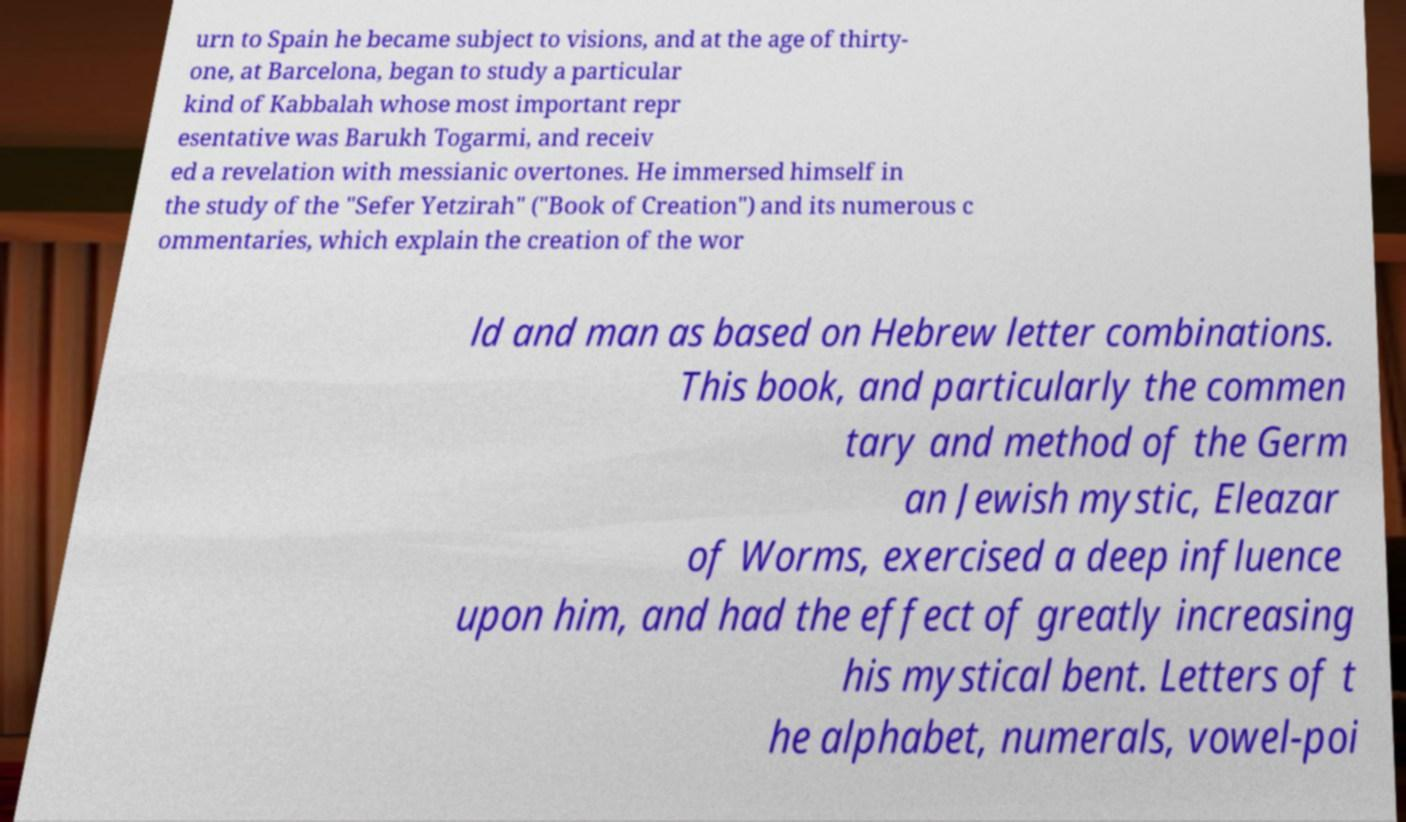Can you accurately transcribe the text from the provided image for me? urn to Spain he became subject to visions, and at the age of thirty- one, at Barcelona, began to study a particular kind of Kabbalah whose most important repr esentative was Barukh Togarmi, and receiv ed a revelation with messianic overtones. He immersed himself in the study of the "Sefer Yetzirah" ("Book of Creation") and its numerous c ommentaries, which explain the creation of the wor ld and man as based on Hebrew letter combinations. This book, and particularly the commen tary and method of the Germ an Jewish mystic, Eleazar of Worms, exercised a deep influence upon him, and had the effect of greatly increasing his mystical bent. Letters of t he alphabet, numerals, vowel-poi 